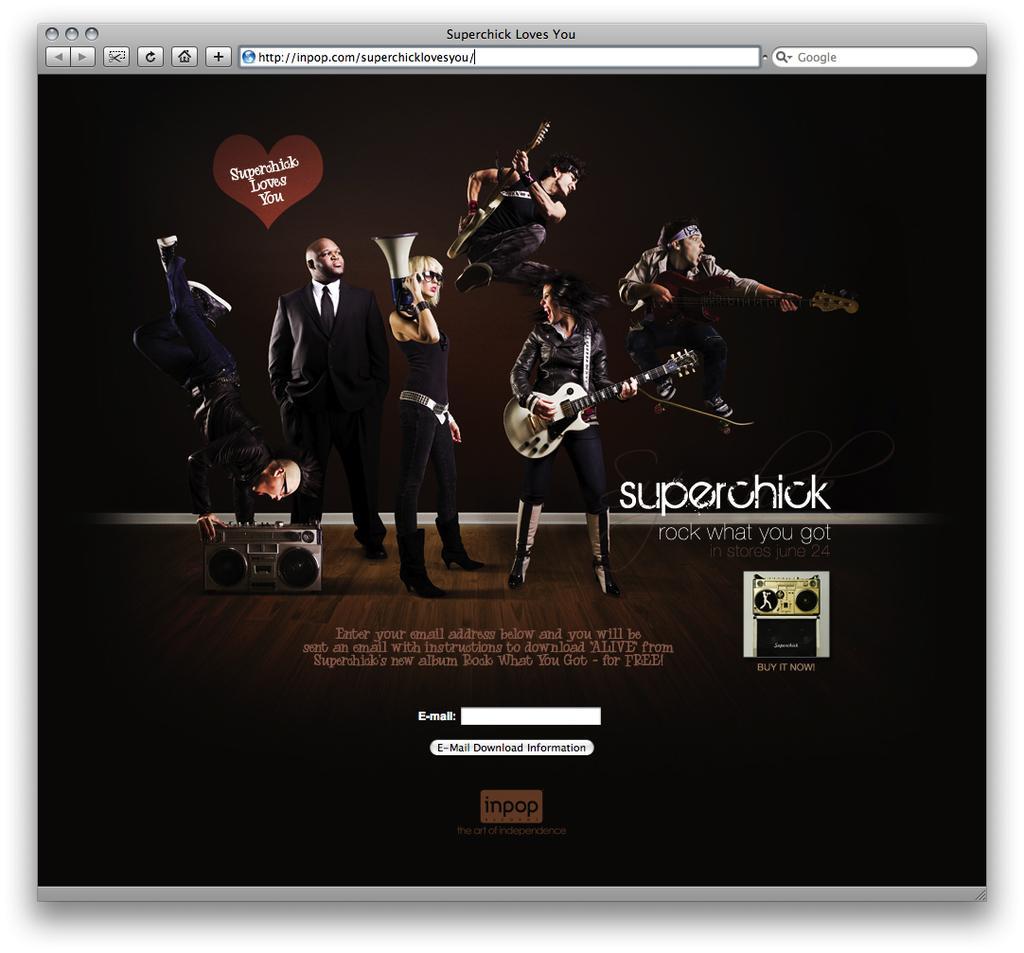Describe this image in one or two sentences. In the picture we can see a login page with an image of some people are playing the musical instruments and beside it we can see the name super chick. 